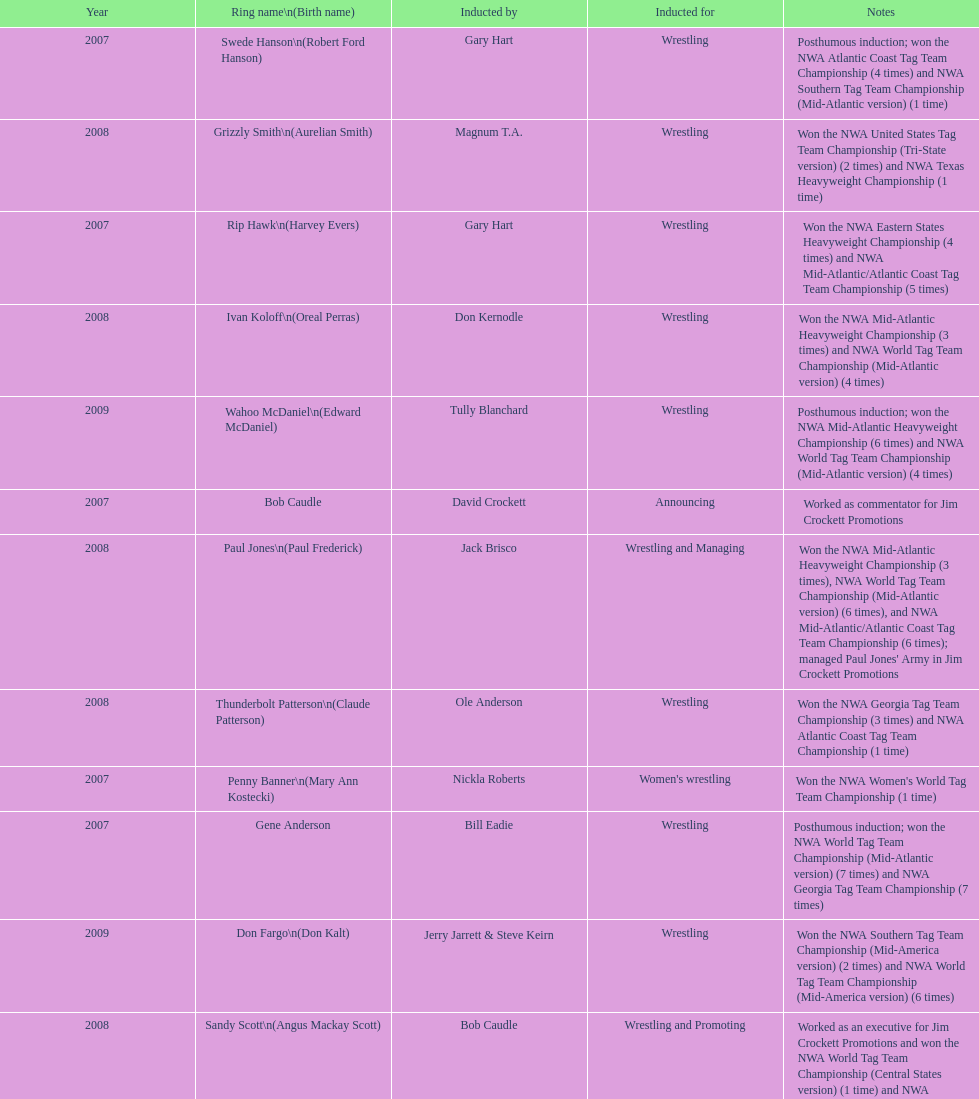How many members were introduced for declaring? 2. 